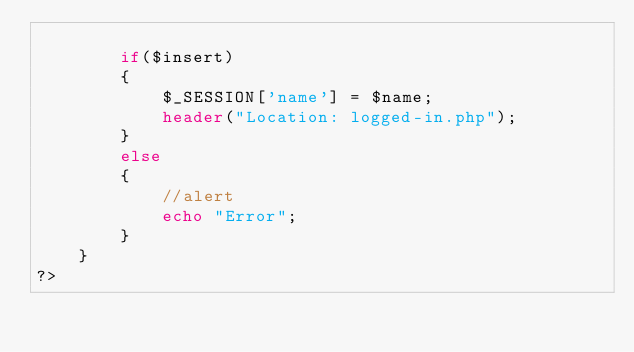Convert code to text. <code><loc_0><loc_0><loc_500><loc_500><_PHP_>
        if($insert)
        {
            $_SESSION['name'] = $name;
            header("Location: logged-in.php");
        }
        else
        {
            //alert
            echo "Error";
        }
    }
?></code> 